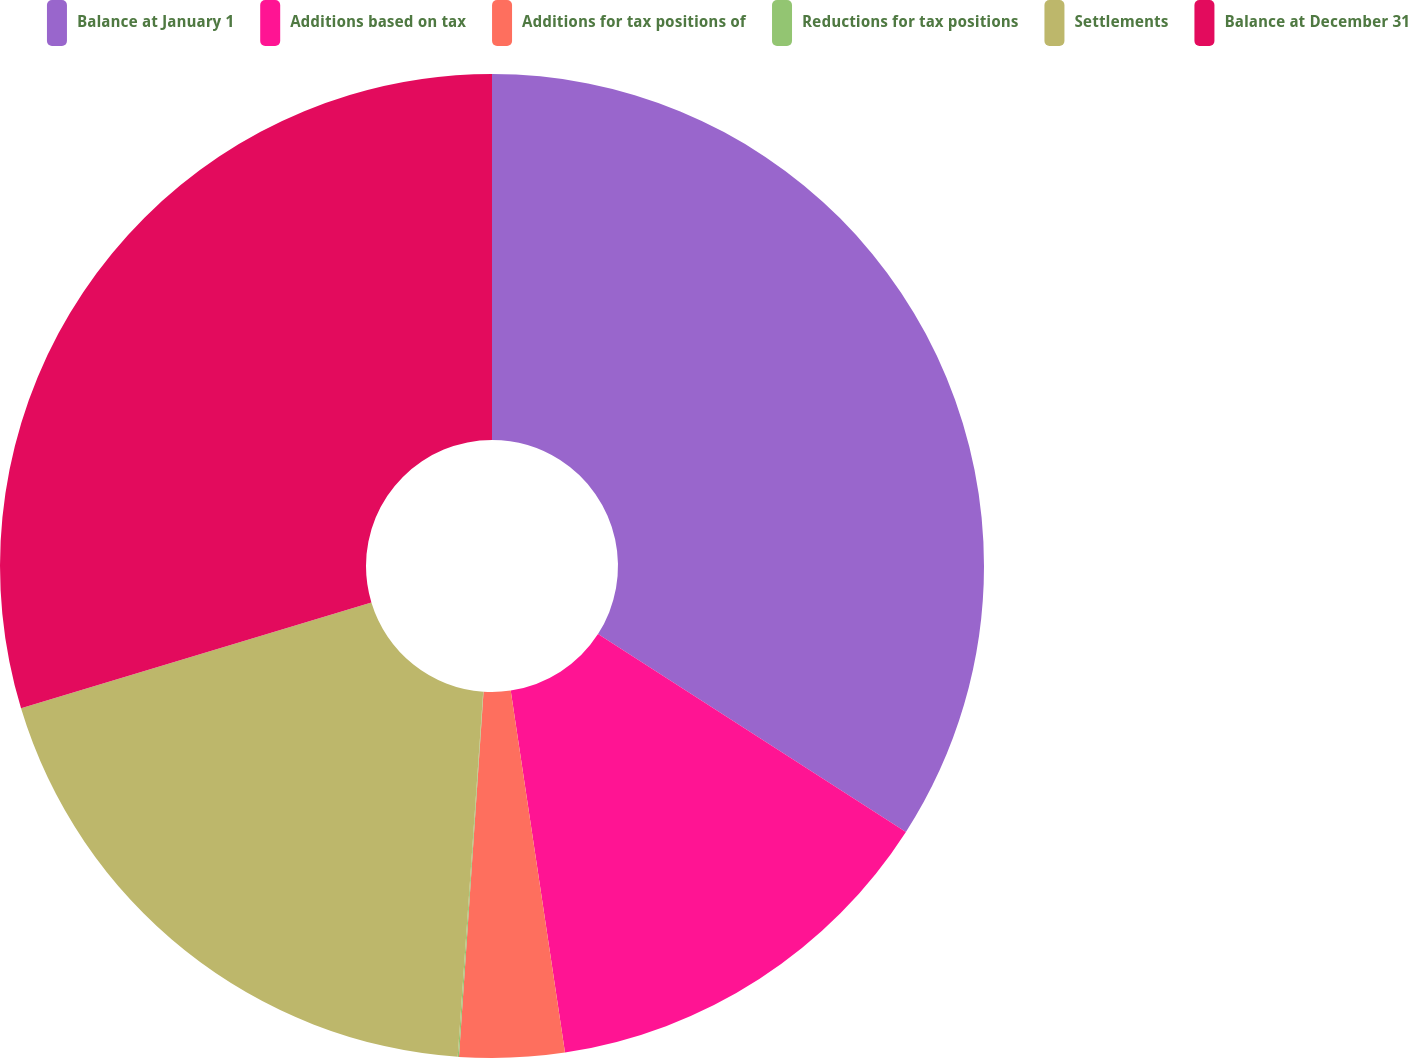Convert chart to OTSL. <chart><loc_0><loc_0><loc_500><loc_500><pie_chart><fcel>Balance at January 1<fcel>Additions based on tax<fcel>Additions for tax positions of<fcel>Reductions for tax positions<fcel>Settlements<fcel>Balance at December 31<nl><fcel>34.09%<fcel>13.54%<fcel>3.44%<fcel>0.04%<fcel>19.22%<fcel>29.67%<nl></chart> 